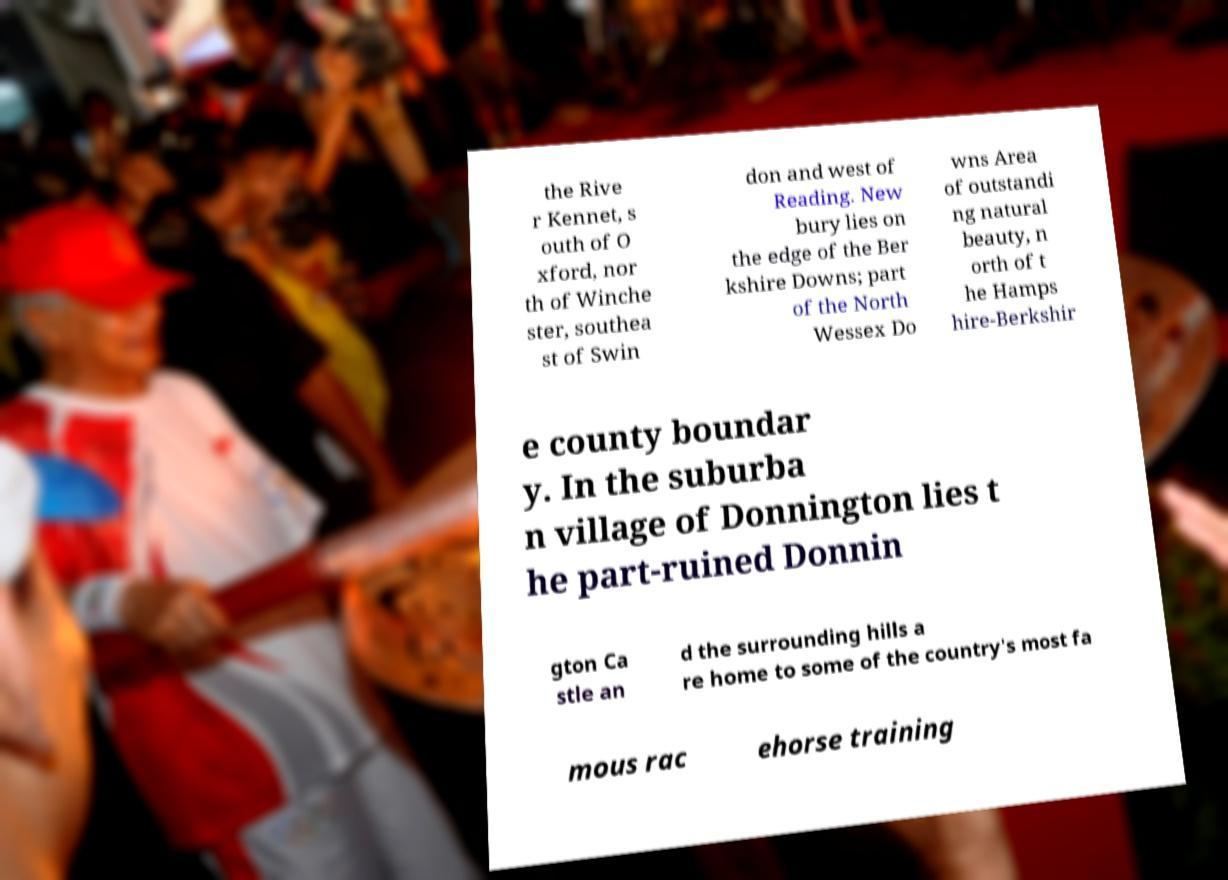There's text embedded in this image that I need extracted. Can you transcribe it verbatim? the Rive r Kennet, s outh of O xford, nor th of Winche ster, southea st of Swin don and west of Reading. New bury lies on the edge of the Ber kshire Downs; part of the North Wessex Do wns Area of outstandi ng natural beauty, n orth of t he Hamps hire-Berkshir e county boundar y. In the suburba n village of Donnington lies t he part-ruined Donnin gton Ca stle an d the surrounding hills a re home to some of the country's most fa mous rac ehorse training 